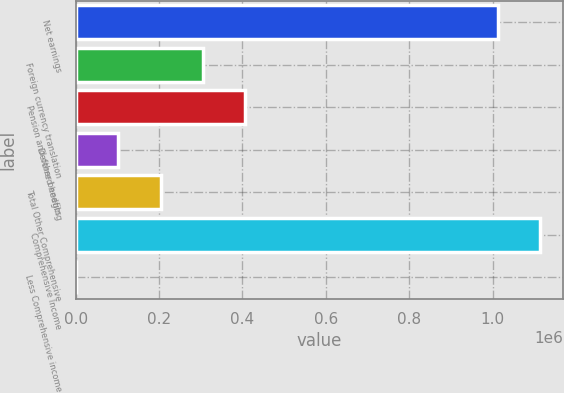Convert chart to OTSL. <chart><loc_0><loc_0><loc_500><loc_500><bar_chart><fcel>Net earnings<fcel>Foreign currency translation<fcel>Pension and other benefits<fcel>Deferred hedging<fcel>Total Other Comprehensive<fcel>Comprehensive Income<fcel>Less Comprehensive income<nl><fcel>1.01258e+06<fcel>305232<fcel>406904<fcel>101889<fcel>203560<fcel>1.11425e+06<fcel>217<nl></chart> 